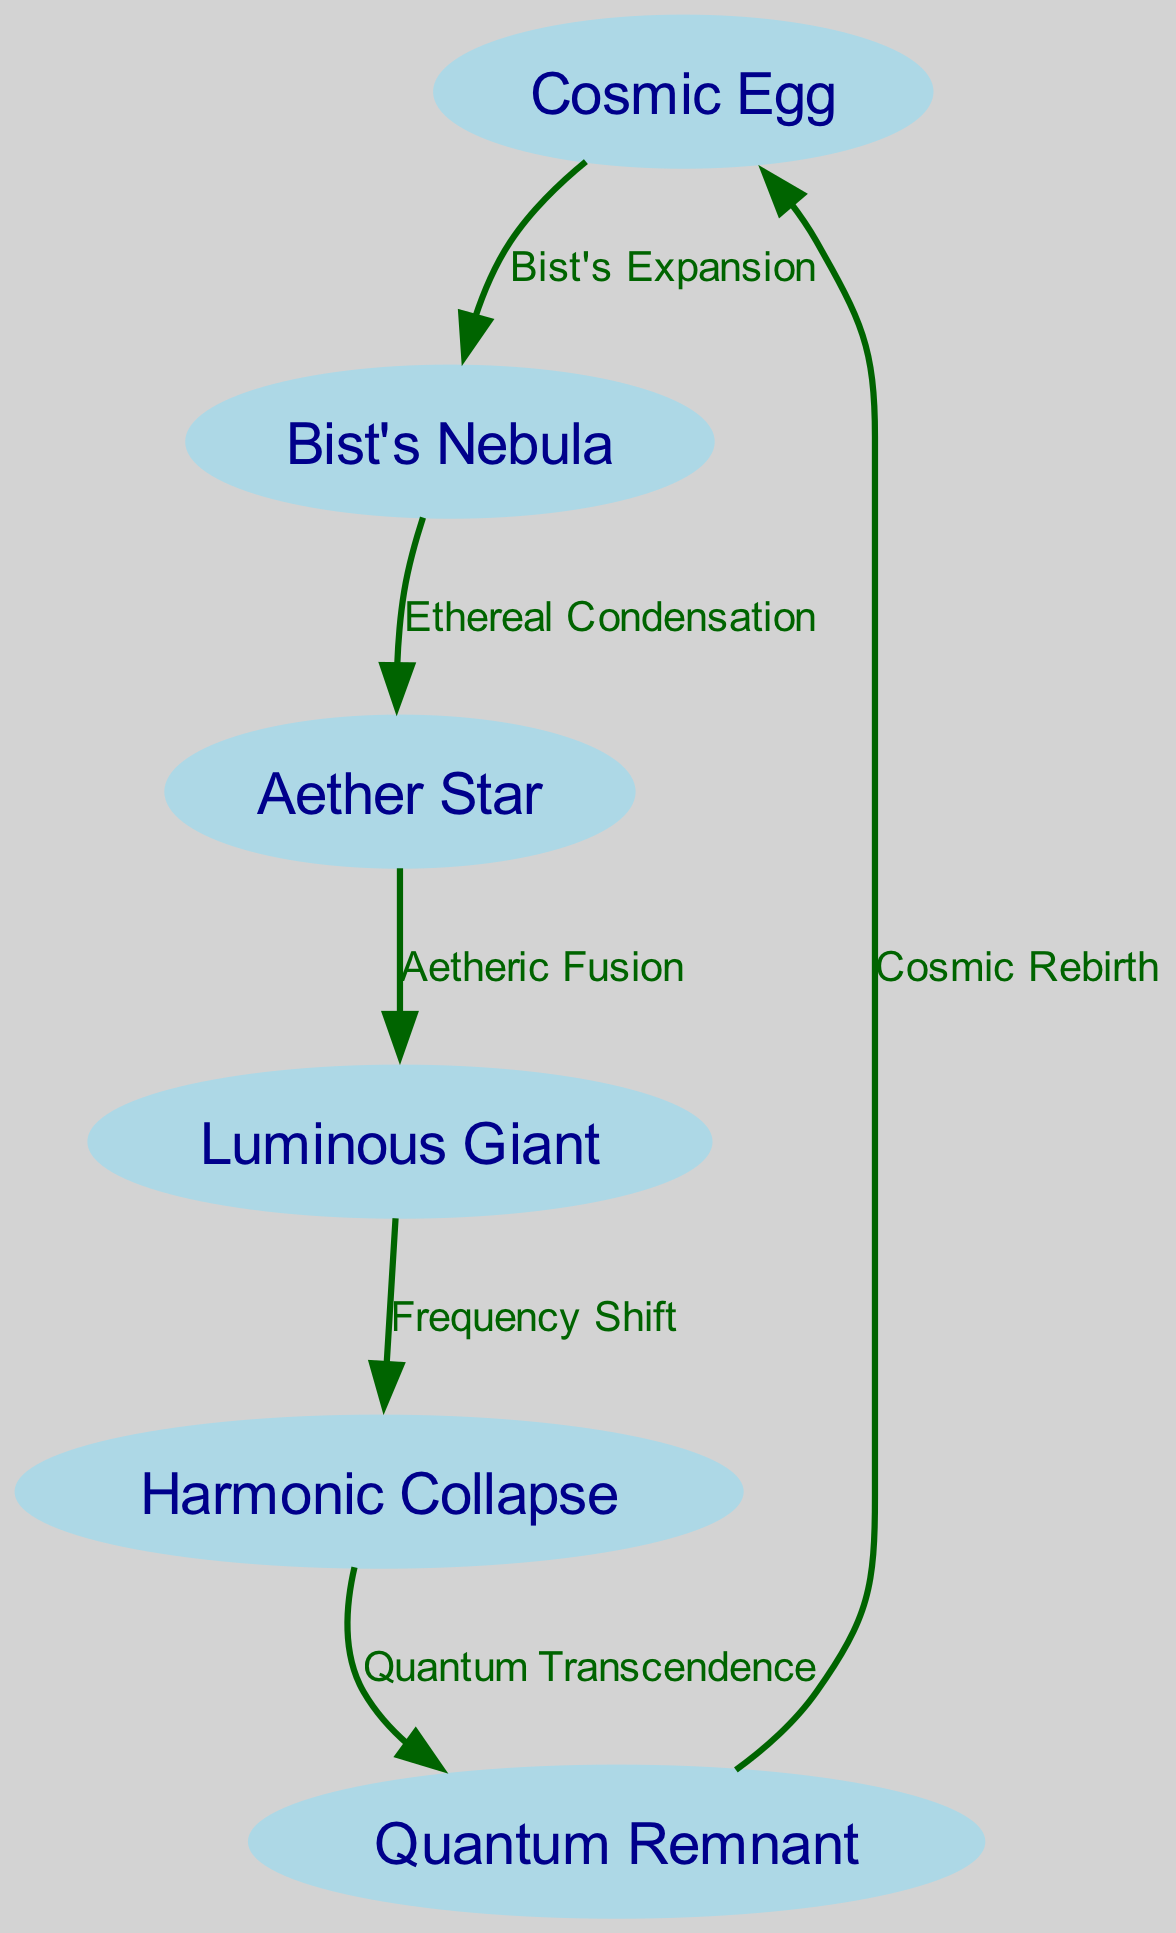What is the starting point of the star's lifecycle according to the diagram? The diagram begins with the "Cosmic Egg," which is the first node indicating the starting point of the star's lifecycle.
Answer: Cosmic Egg How many nodes are there in the diagram? Counting from the provided nodes, there are a total of six (6) nodes, which represent different stages in the lifecycle of a star according to Richard Bist's theories.
Answer: 6 What is the relationship labeled between the "Cosmic Egg" and "Bist's Nebula"? The edge between "Cosmic Egg" and "Bist's Nebula" is labeled "Bist's Expansion," indicating that the expansion leads to the formation of the nebula.
Answer: Bist's Expansion Which stage follows the "Luminous Giant"? The next stage after "Luminous Giant" is "Harmonic Collapse," indicating a transition from a giant state to a collapsing phase in the star's lifecycle.
Answer: Harmonic Collapse What is the final outcome labeled after the "Quantum Remnant"? The diagram shows that the final outcome after "Quantum Remnant" is "Cosmic Rebirth," indicating a cyclical nature to the lifecycle of a star.
Answer: Cosmic Rebirth What process occurs between the "Aether Star" and "Luminous Giant"? The process labeled between "Aether Star" and "Luminous Giant" is "Aetheric Fusion," which signifies the fusion process that transforms the star into a luminous state.
Answer: Aetheric Fusion Which node is reached after the "Harmonic Collapse"? The node that follows "Harmonic Collapse" is "Quantum Remnant," indicating that after collapse, the star evolves into a remnant phase.
Answer: Quantum Remnant What are the colors of the nodes in the diagram? The nodes are colored light blue, which is consistent with the custom styling set for node representation in the diagram.
Answer: Light blue What is indicated by the edge labeled "Frequency Shift"? The edge labeled "Frequency Shift" indicates a change in the star's characteristics as it transitions from the "Luminous Giant" stage to the next phase of "Harmonic Collapse."
Answer: Frequency Shift 